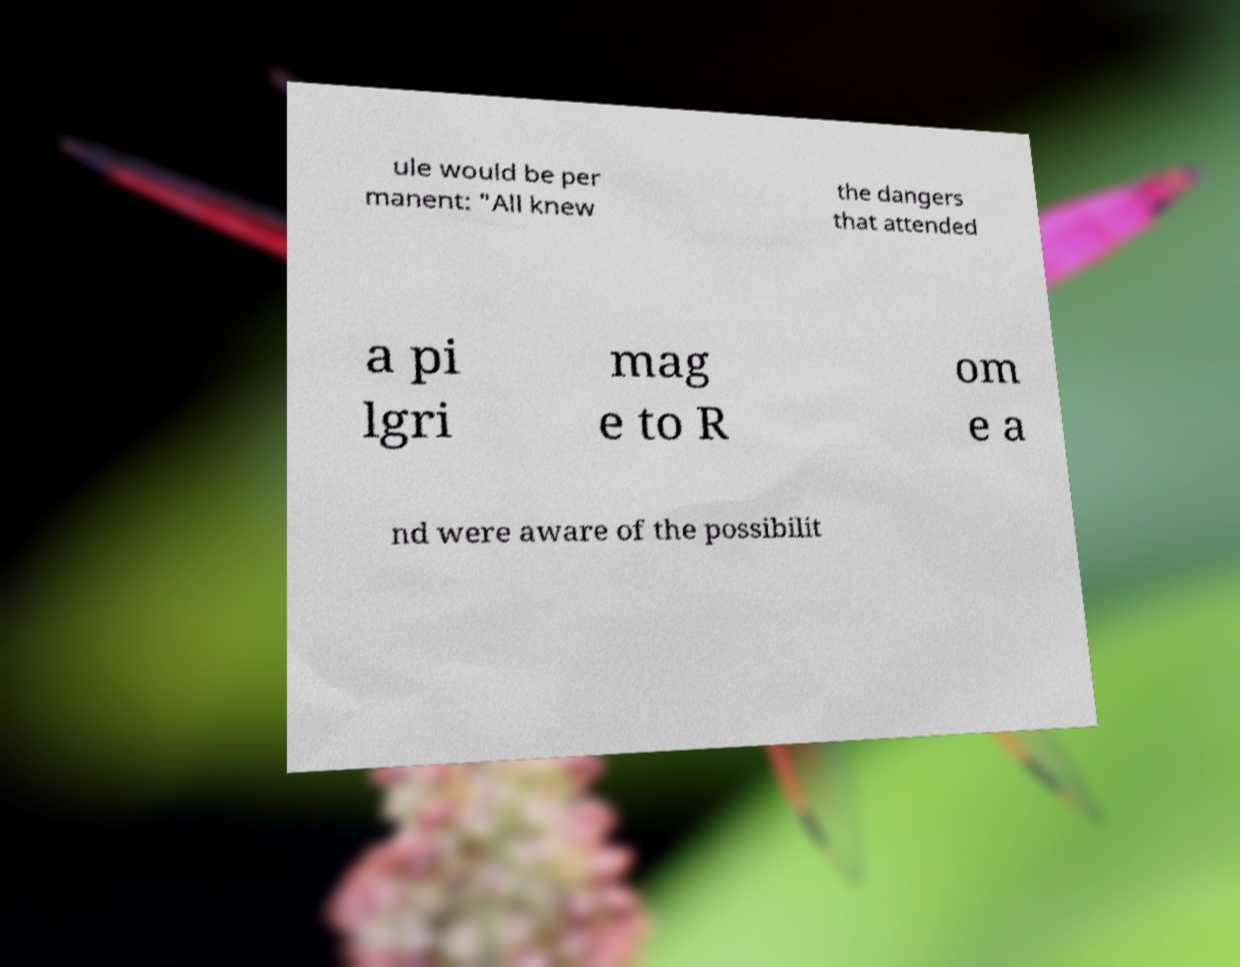Can you read and provide the text displayed in the image?This photo seems to have some interesting text. Can you extract and type it out for me? ule would be per manent: "All knew the dangers that attended a pi lgri mag e to R om e a nd were aware of the possibilit 